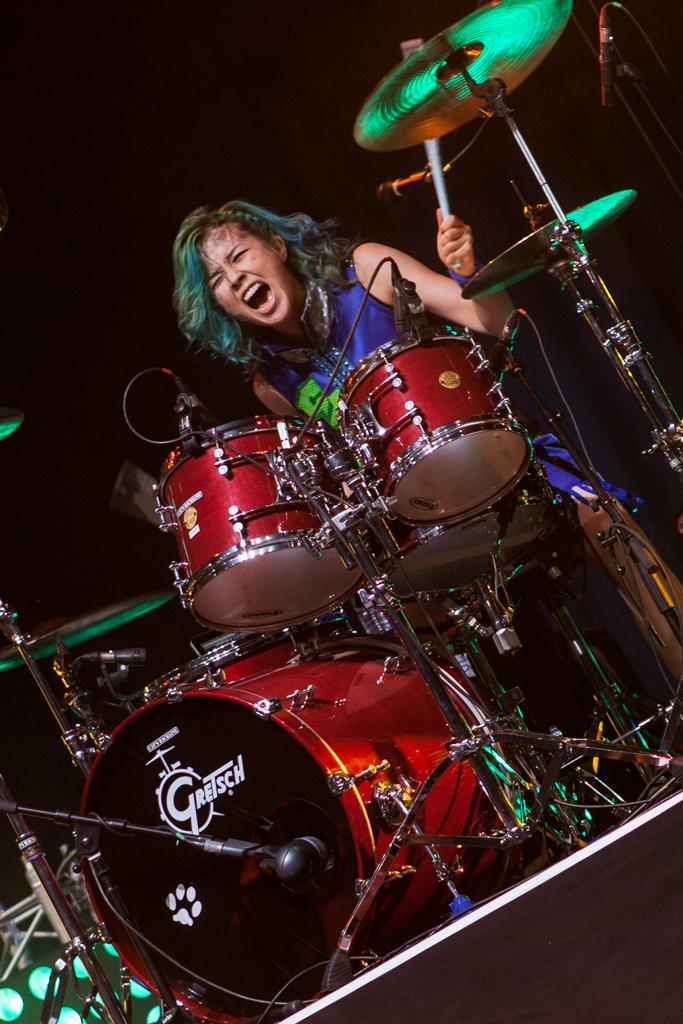Please provide a concise description of this image. In this picture there is a girl in the center of the image and there is a drum set in front of her and there is a mic on the top right side of the image and there are lights at the bottom side of the image. 